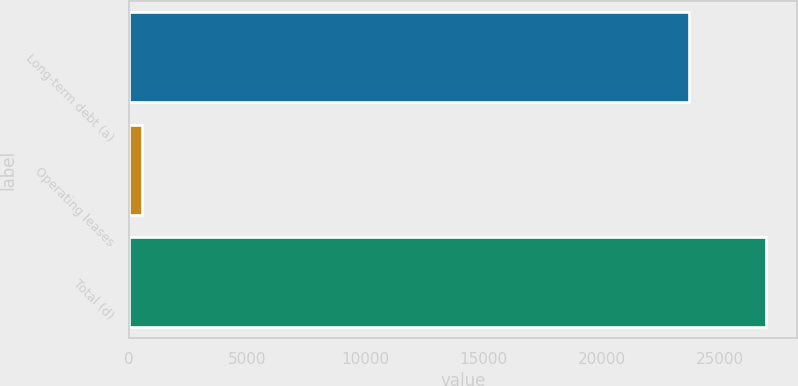<chart> <loc_0><loc_0><loc_500><loc_500><bar_chart><fcel>Long-term debt (a)<fcel>Operating leases<fcel>Total (d)<nl><fcel>23694<fcel>546<fcel>26931<nl></chart> 